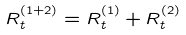Convert formula to latex. <formula><loc_0><loc_0><loc_500><loc_500>R _ { t } ^ { ( 1 + 2 ) } = R _ { t } ^ { ( 1 ) } + R _ { t } ^ { ( 2 ) }</formula> 